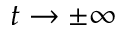Convert formula to latex. <formula><loc_0><loc_0><loc_500><loc_500>t \to \pm \infty</formula> 